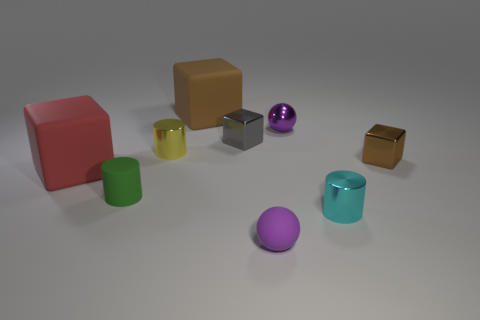Is there a small yellow metallic object of the same shape as the red object?
Ensure brevity in your answer.  No. Does the tiny purple thing behind the small purple matte thing have the same shape as the shiny thing that is in front of the big red rubber block?
Give a very brief answer. No. What is the shape of the object that is behind the gray thing and to the right of the brown rubber cube?
Give a very brief answer. Sphere. Is there a gray matte cylinder of the same size as the purple metallic ball?
Give a very brief answer. No. There is a tiny matte ball; does it have the same color as the cube that is to the right of the purple shiny thing?
Offer a very short reply. No. What is the material of the cyan object?
Provide a succinct answer. Metal. What is the color of the small metallic cylinder left of the gray shiny object?
Provide a short and direct response. Yellow. How many small metal spheres have the same color as the matte ball?
Your answer should be compact. 1. What number of tiny metal objects are in front of the gray shiny thing and behind the matte cylinder?
Make the answer very short. 2. There is a yellow shiny object that is the same size as the cyan thing; what is its shape?
Your answer should be very brief. Cylinder. 